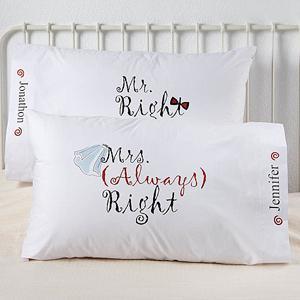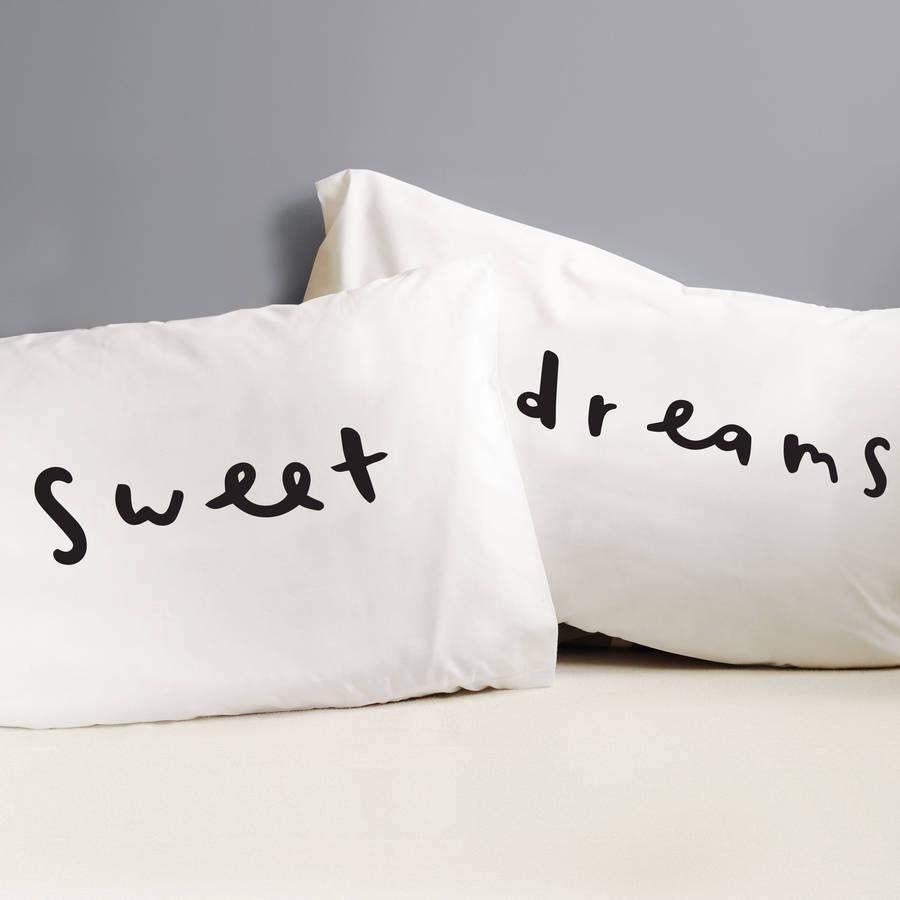The first image is the image on the left, the second image is the image on the right. For the images displayed, is the sentence "Some of the pillows mention spoons." factually correct? Answer yes or no. No. 